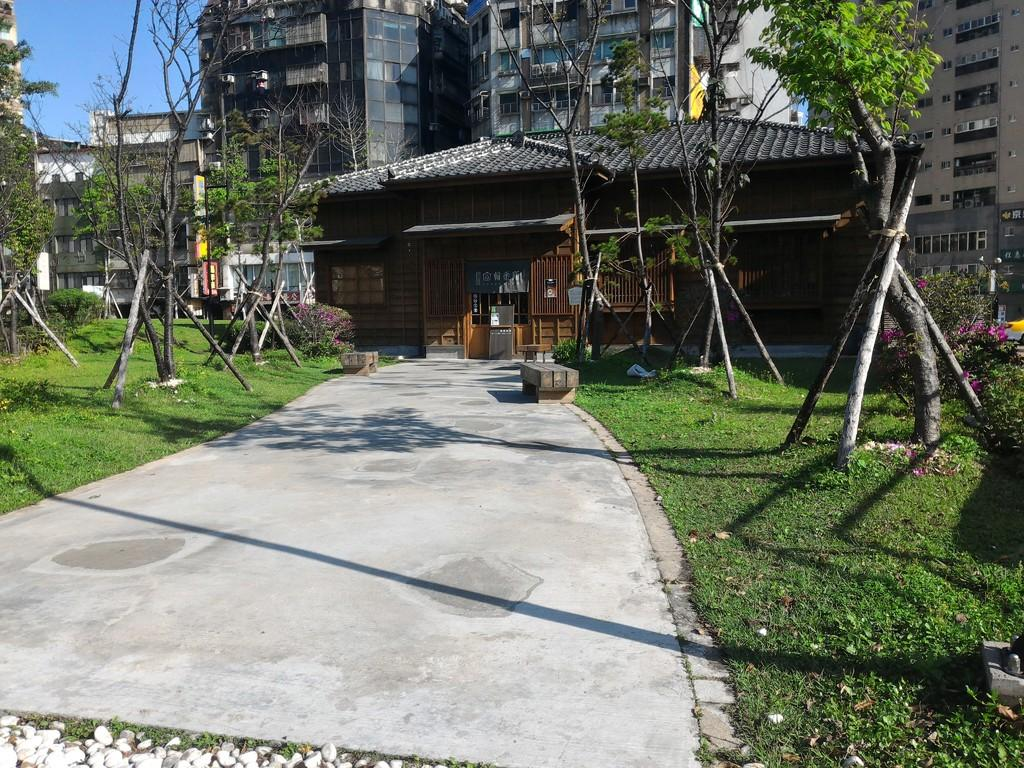What type of structure is in the image? There is a house in the image. What can be seen behind the house? There are many buildings behind the house. What type of vegetation is visible in the image? There are trees visible in the image. What type of surface is present in the image? There is a path in the image. What type of ground cover is present in the image? There is grass in the image. How many cows are grazing on the grass in the image? There are no cows present in the image; it only features a house, buildings, trees, a path, and grass. 